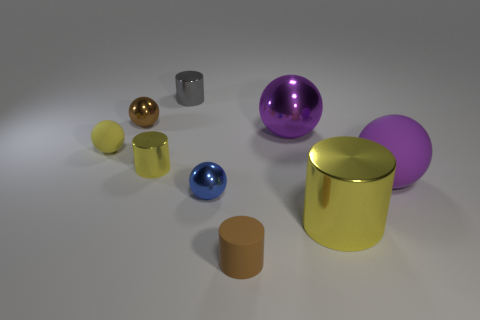Subtract all big yellow metallic cylinders. How many cylinders are left? 3 Subtract all yellow balls. How many balls are left? 4 Subtract all purple blocks. How many yellow cylinders are left? 2 Subtract all cylinders. How many objects are left? 5 Subtract 0 cyan spheres. How many objects are left? 9 Subtract all green balls. Subtract all red cylinders. How many balls are left? 5 Subtract all large shiny cylinders. Subtract all big purple metal balls. How many objects are left? 7 Add 9 blue balls. How many blue balls are left? 10 Add 5 purple balls. How many purple balls exist? 7 